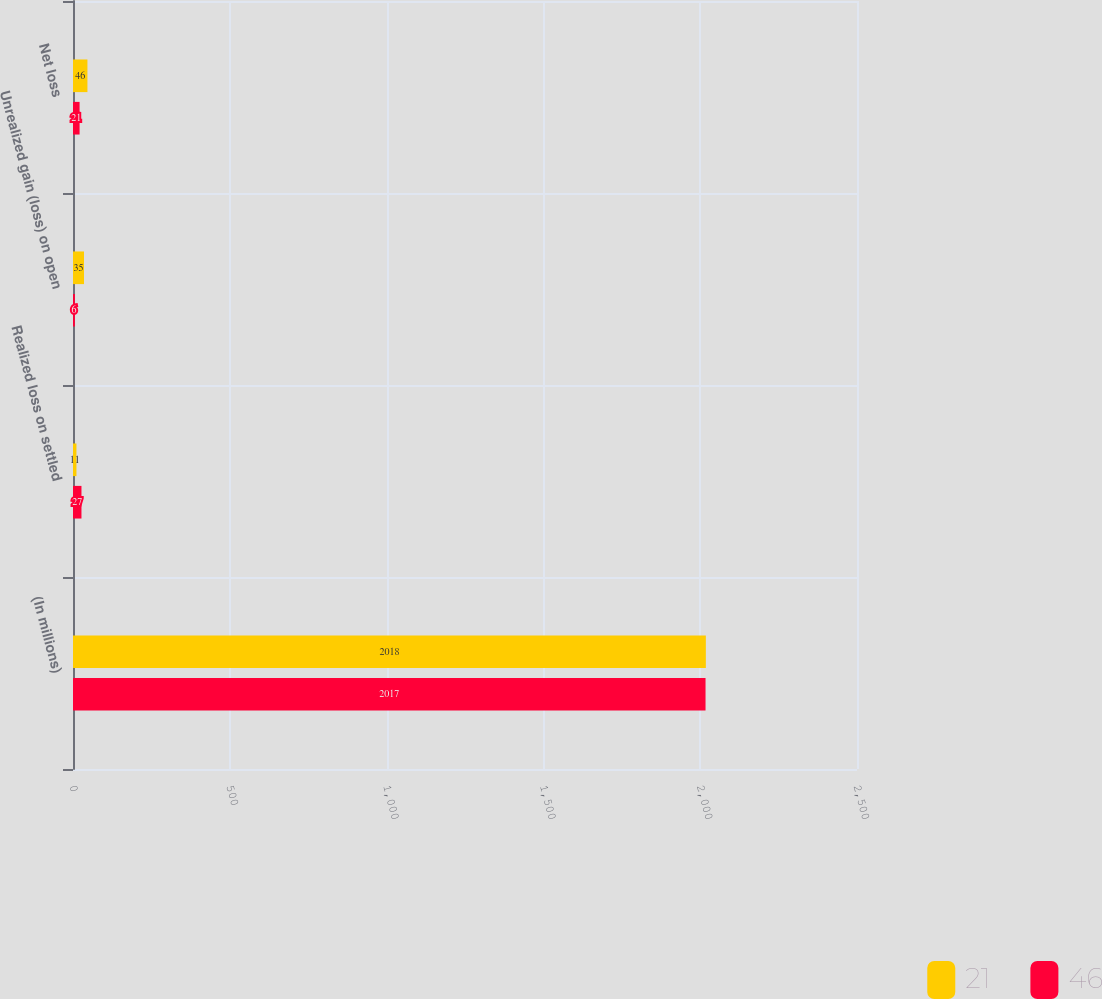Convert chart to OTSL. <chart><loc_0><loc_0><loc_500><loc_500><stacked_bar_chart><ecel><fcel>(In millions)<fcel>Realized loss on settled<fcel>Unrealized gain (loss) on open<fcel>Net loss<nl><fcel>21<fcel>2018<fcel>11<fcel>35<fcel>46<nl><fcel>46<fcel>2017<fcel>27<fcel>6<fcel>21<nl></chart> 